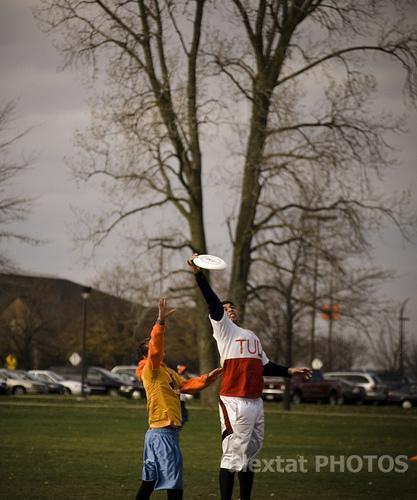How many people are in the picture?
Give a very brief answer. 2. How many people are there?
Give a very brief answer. 2. 